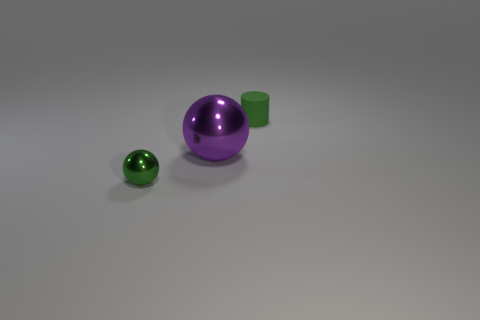How many objects are there in total, and can you describe their colors? In total, there are three objects. Starting with the smallest, there is a small shiny green sphere, a medium-sized matte green cylinder, and a large shiny purple sphere. 